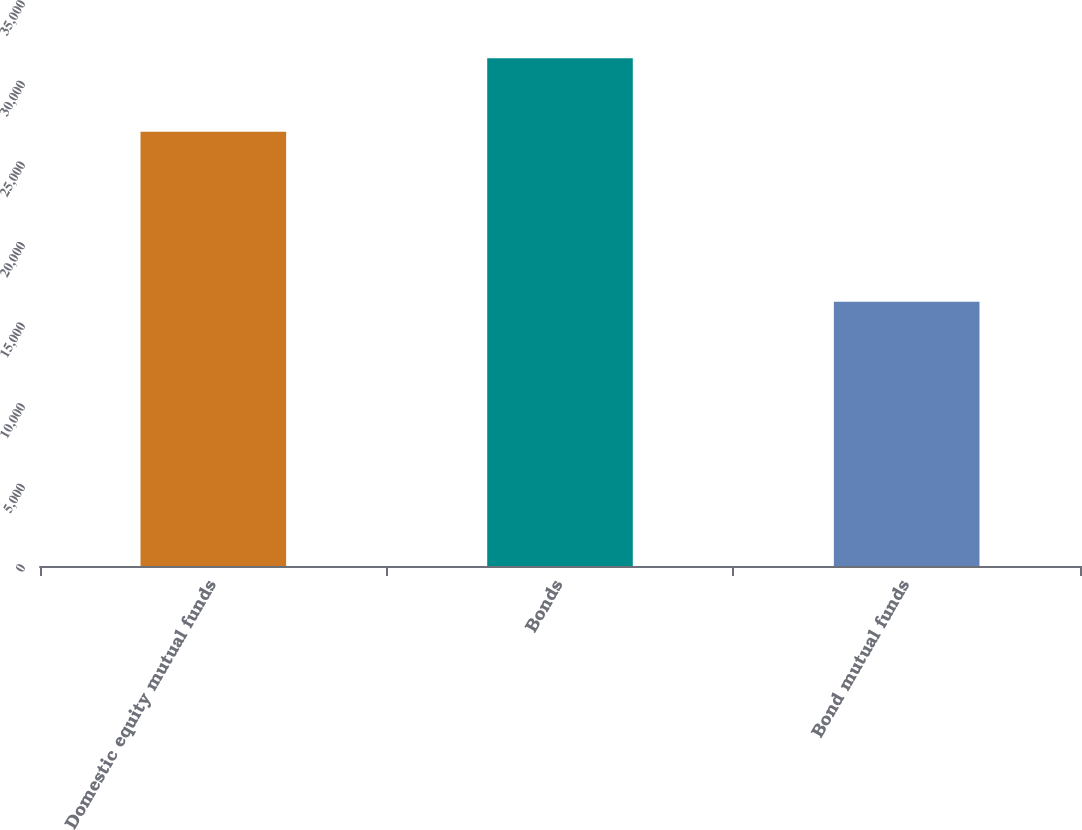Convert chart to OTSL. <chart><loc_0><loc_0><loc_500><loc_500><bar_chart><fcel>Domestic equity mutual funds<fcel>Bonds<fcel>Bond mutual funds<nl><fcel>26950<fcel>31511<fcel>16391<nl></chart> 